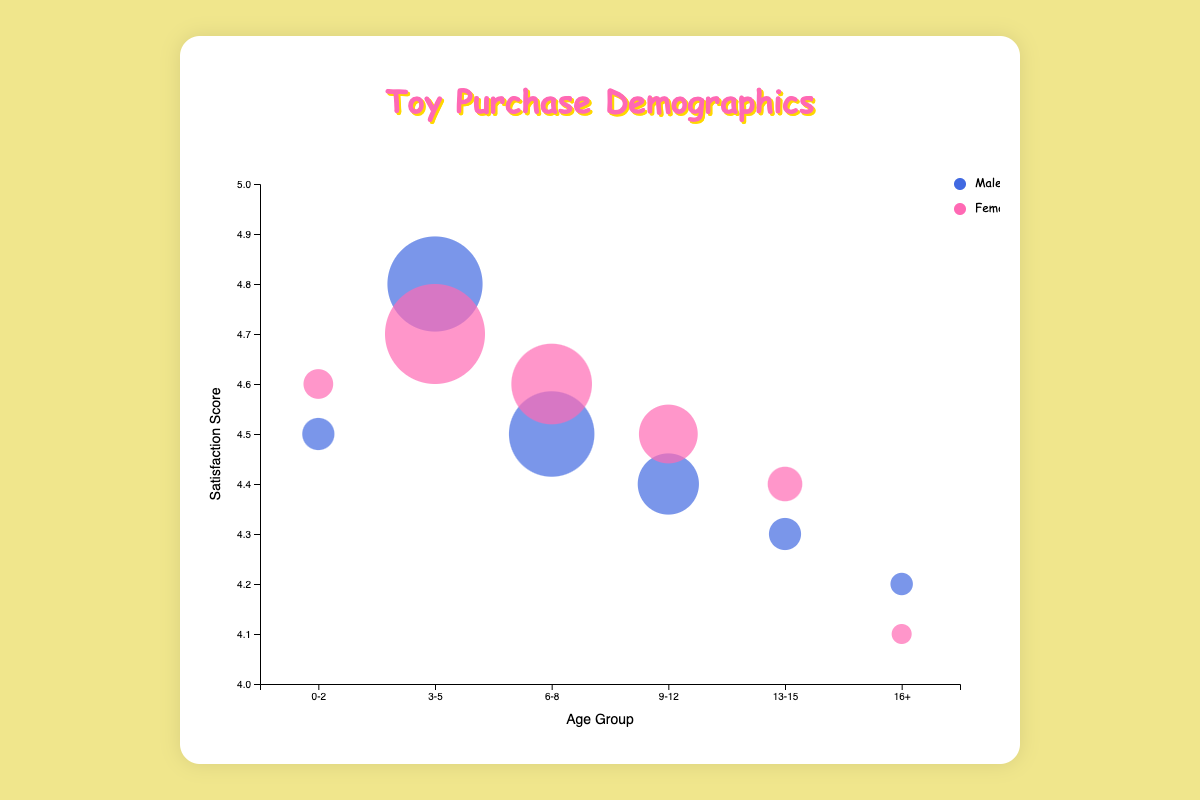What is the title of the bubble chart? The title of a chart is typically displayed at the top and provides information about what the chart represents. In this case, it is centered and mentioned in the code as well.
Answer: Toy Purchase Demographics Which axis represents the age groups? The age groups are listed along the horizontal (x) axis, as indicated by the 'Age Group' label derived from the code.
Answer: Horizontal (x) axis What do the colors of the bubbles represent? The colors of the bubbles represent the gender. Blue is used for Males, and pink is used for Females as per the color scale description in the code.
Answer: Gender What does a larger bubble size indicate? A larger bubble size represents a higher average number of toy purchases. The size of each bubble is scaled according to the number of average purchases.
Answer: Higher average purchases Which age group has the highest average toy purchases for females? Based on the y axis values, the 3-5 age group for females (Barbie) has the highest average toy purchases, indicated by the largest bubble for females.
Answer: 3-5 Which company has the lowest satisfaction score, and for which age group and gender? By examining the y axis, the smallest y-value for bubbles indicates the lowest satisfaction score. The bubble for Funko in the 16+ age group for females has the lowest satisfaction score of 4.1.
Answer: Funko, age group 16+, female How many total companies are represented in the bubble chart? Each bubble represents a unique company; there are 12 bubbles in the chart, hence there are 12 companies.
Answer: 12 For the same age group, which gender has more purchases on average for the 3-5 age group? By comparing the size of the bubbles for the 3-5 age group, the female bubble (Barbie, 2600) is larger than the male bubble (Lego, 2500), indicating females make more purchases on average.
Answer: Female What is the satisfaction score for the company with the highest purchases? The highest average purchases are by the Barbie company in the 3-5 female age group. The corresponding satisfaction score is 4.7.
Answer: 4.7 